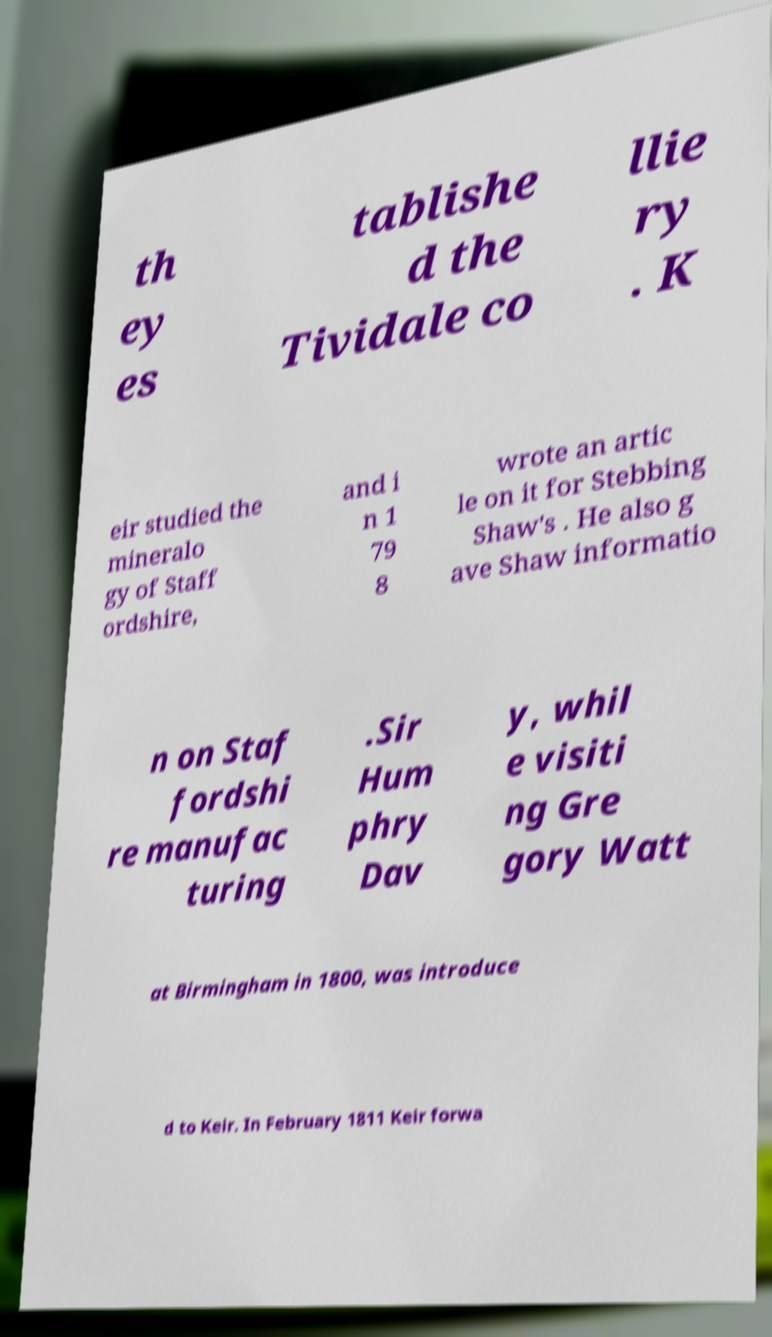There's text embedded in this image that I need extracted. Can you transcribe it verbatim? th ey es tablishe d the Tividale co llie ry . K eir studied the mineralo gy of Staff ordshire, and i n 1 79 8 wrote an artic le on it for Stebbing Shaw's . He also g ave Shaw informatio n on Staf fordshi re manufac turing .Sir Hum phry Dav y, whil e visiti ng Gre gory Watt at Birmingham in 1800, was introduce d to Keir. In February 1811 Keir forwa 